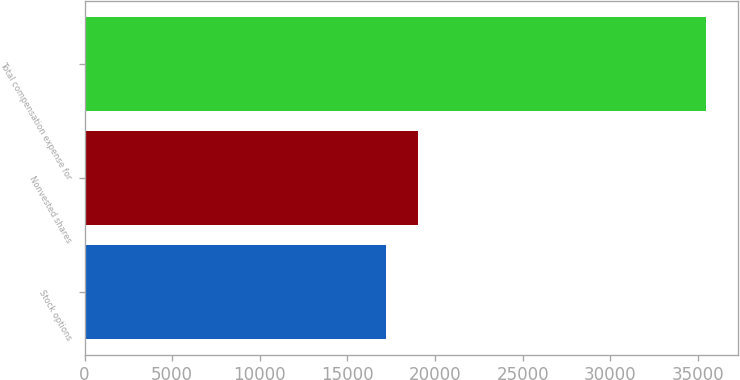Convert chart. <chart><loc_0><loc_0><loc_500><loc_500><bar_chart><fcel>Stock options<fcel>Nonvested shares<fcel>Total compensation expense for<nl><fcel>17171<fcel>19001.7<fcel>35478<nl></chart> 